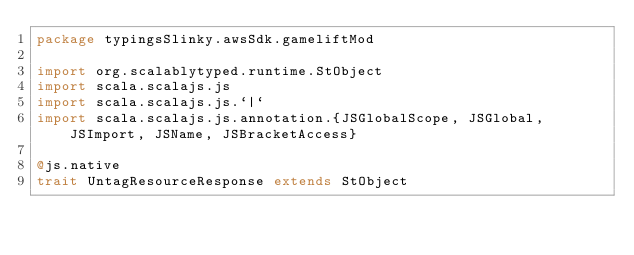<code> <loc_0><loc_0><loc_500><loc_500><_Scala_>package typingsSlinky.awsSdk.gameliftMod

import org.scalablytyped.runtime.StObject
import scala.scalajs.js
import scala.scalajs.js.`|`
import scala.scalajs.js.annotation.{JSGlobalScope, JSGlobal, JSImport, JSName, JSBracketAccess}

@js.native
trait UntagResourceResponse extends StObject
</code> 